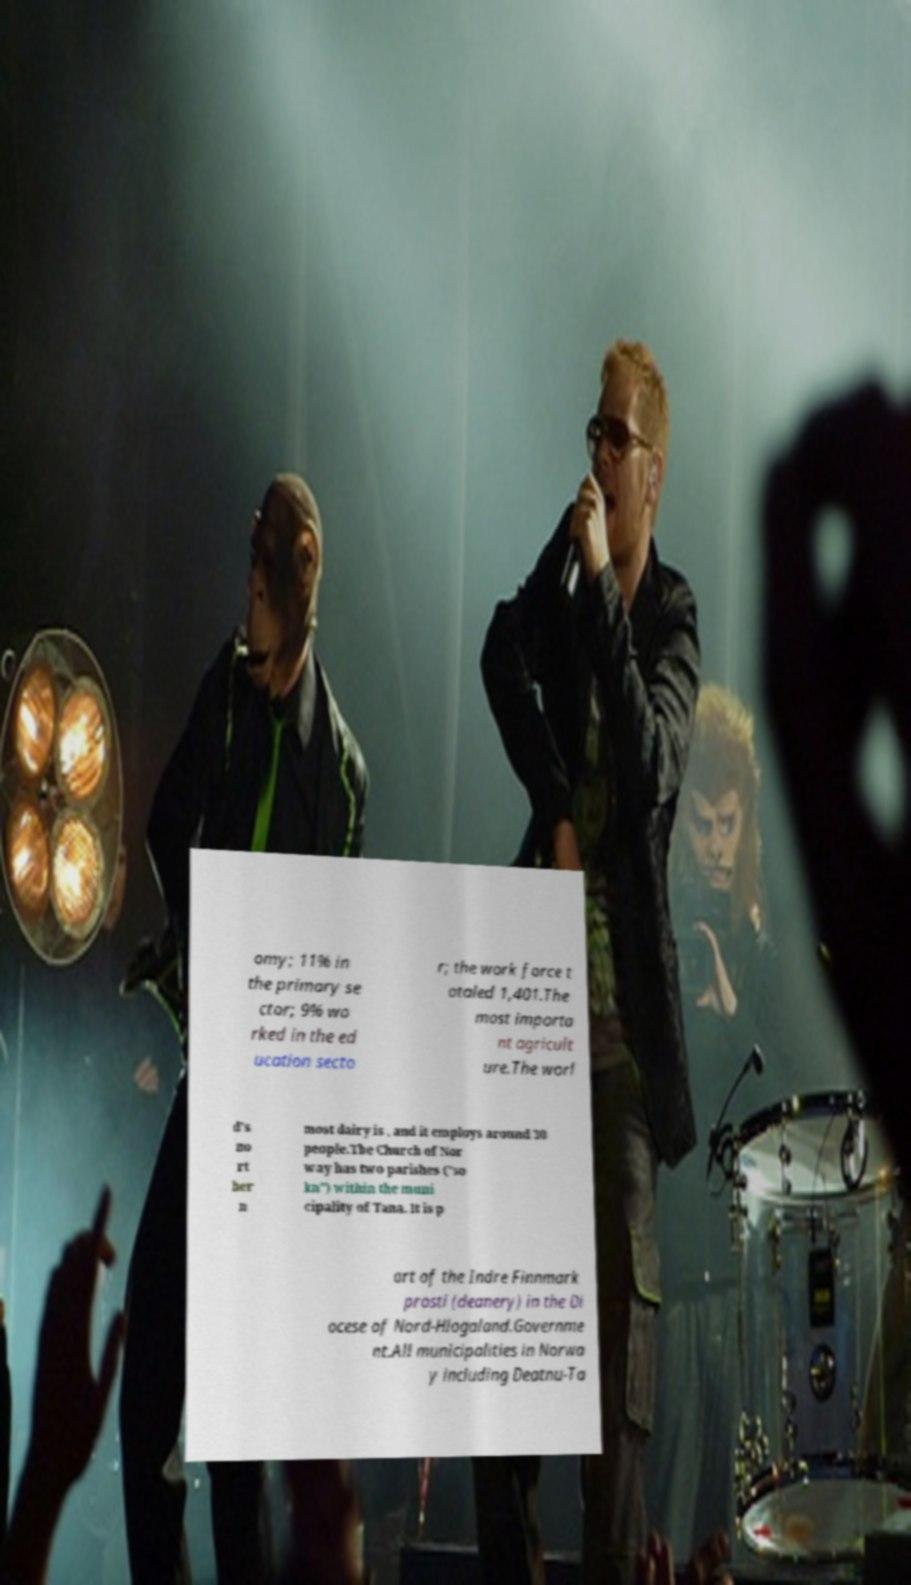There's text embedded in this image that I need extracted. Can you transcribe it verbatim? omy; 11% in the primary se ctor; 9% wo rked in the ed ucation secto r; the work force t otaled 1,401.The most importa nt agricult ure.The worl d's no rt her n most dairy is , and it employs around 30 people.The Church of Nor way has two parishes ("so kn") within the muni cipality of Tana. It is p art of the Indre Finnmark prosti (deanery) in the Di ocese of Nord-Hlogaland.Governme nt.All municipalities in Norwa y including Deatnu-Ta 